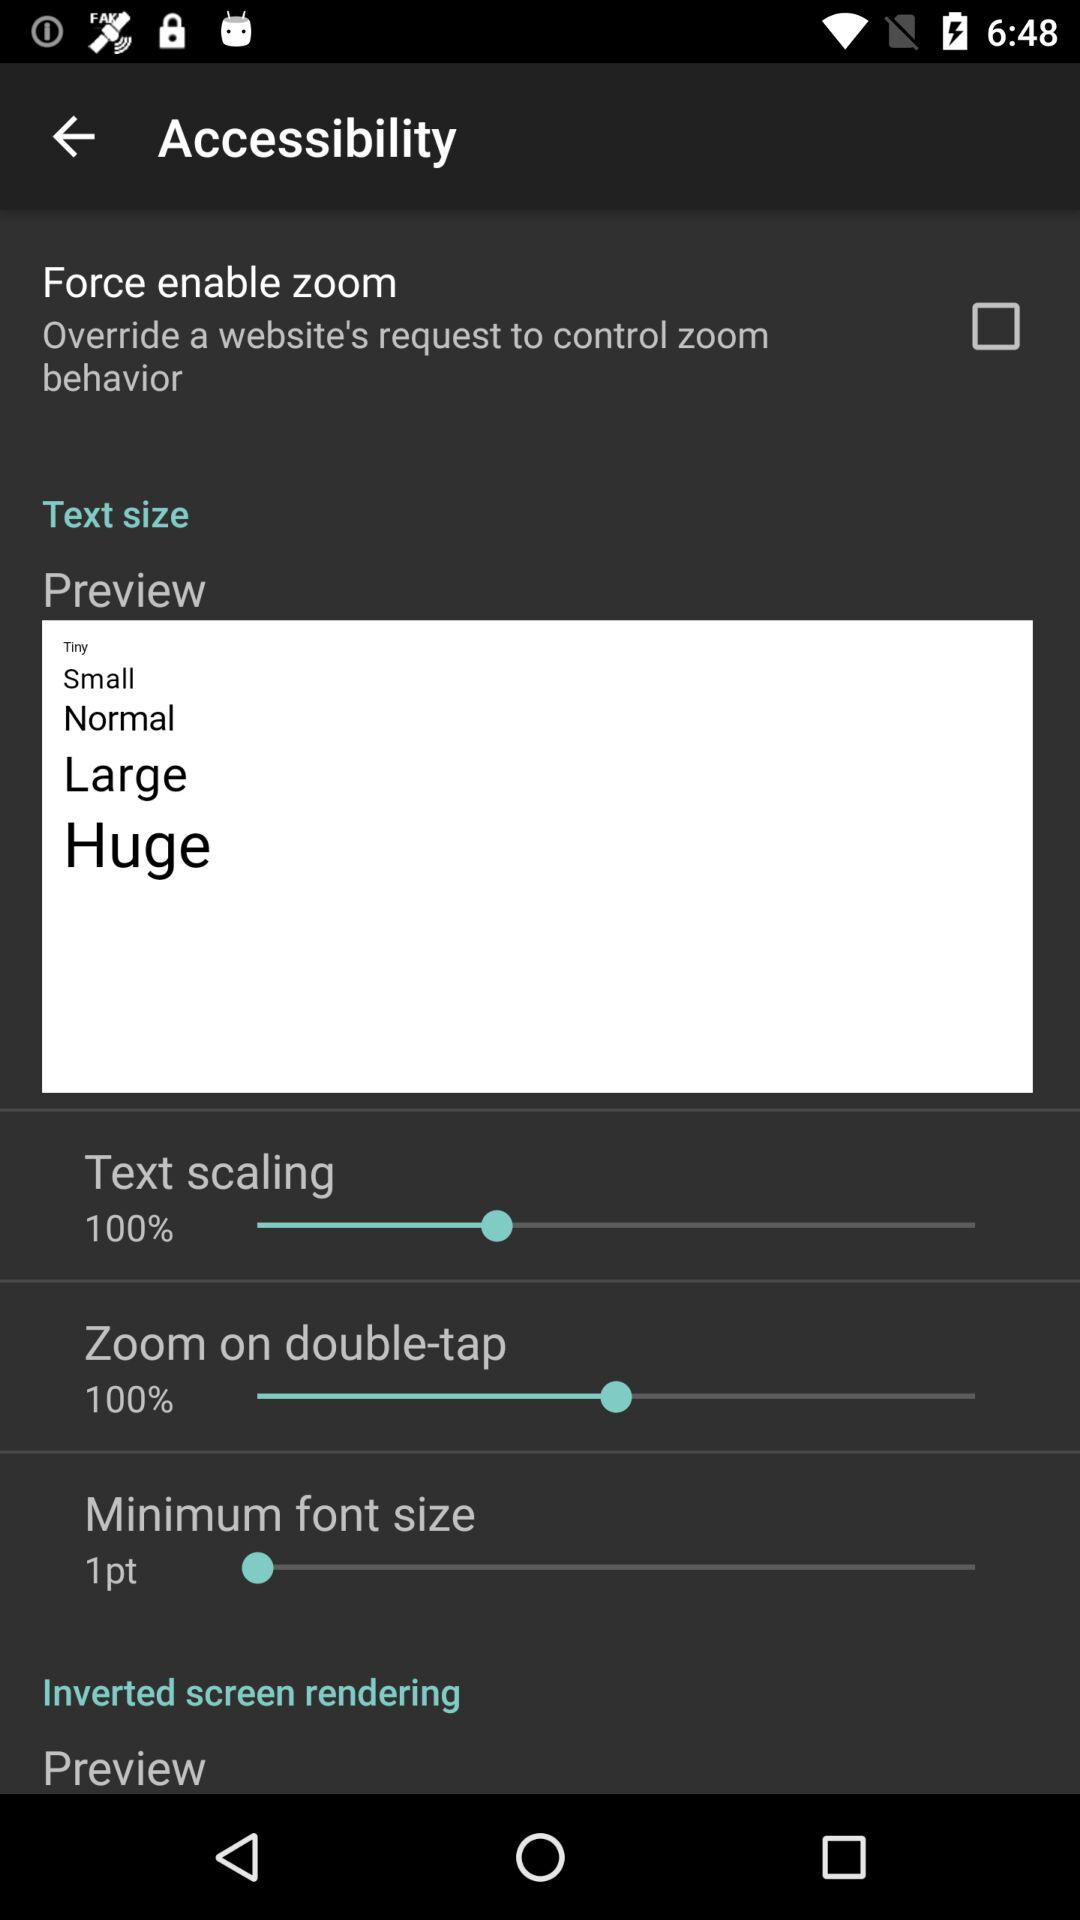What is the percentage of "Text scaling"? The percentage is 100. 